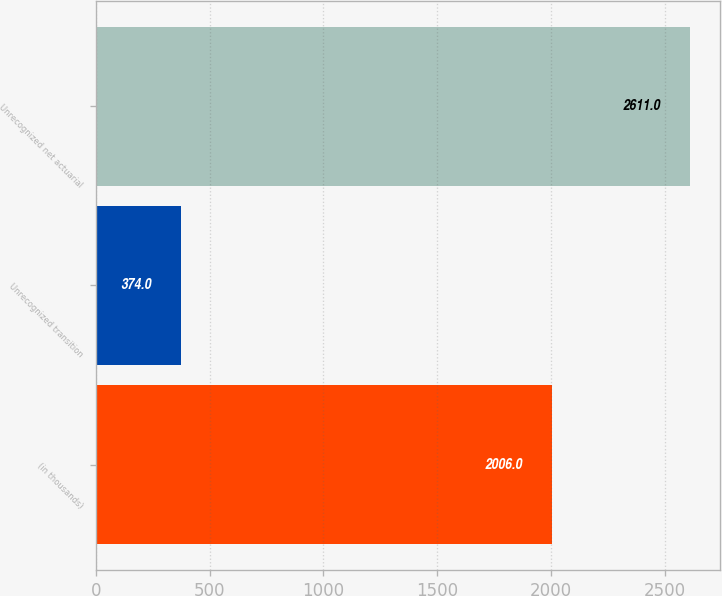Convert chart. <chart><loc_0><loc_0><loc_500><loc_500><bar_chart><fcel>(in thousands)<fcel>Unrecognized transition<fcel>Unrecognized net actuarial<nl><fcel>2006<fcel>374<fcel>2611<nl></chart> 